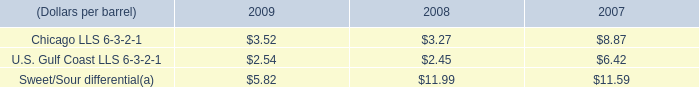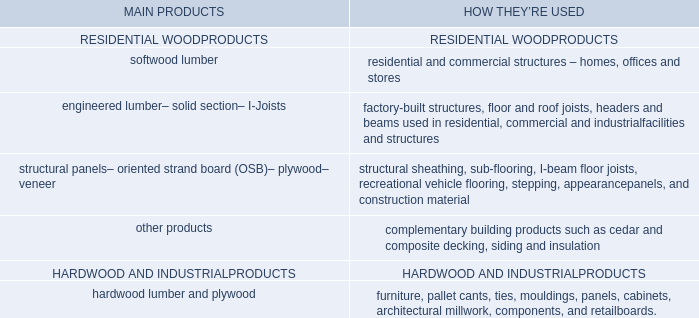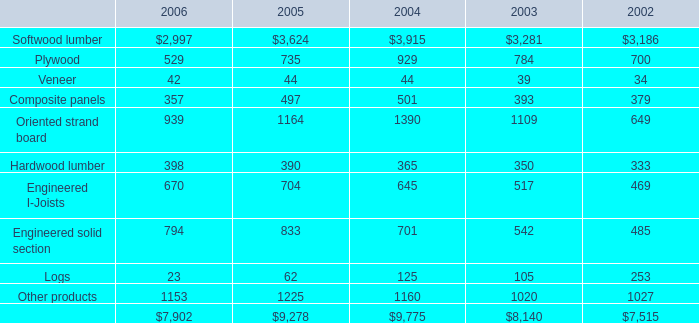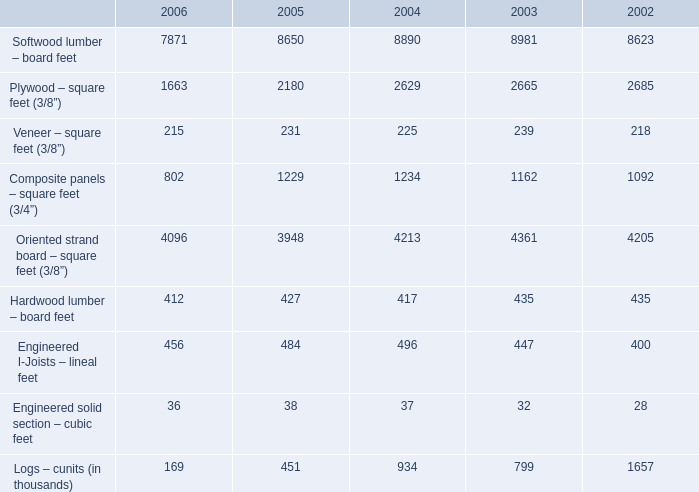What is the average amount of Softwood lumber of 2002, and Softwood lumber – board feet of 2003 ? 
Computations: ((3186.0 + 8981.0) / 2)
Answer: 6083.5. 